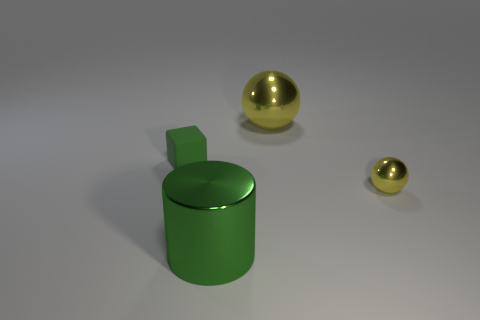Add 3 shiny things. How many objects exist? 7 Subtract all blocks. How many objects are left? 3 Add 1 small gray rubber spheres. How many small gray rubber spheres exist? 1 Subtract 0 brown balls. How many objects are left? 4 Subtract all green cylinders. Subtract all yellow metal spheres. How many objects are left? 1 Add 4 matte objects. How many matte objects are left? 5 